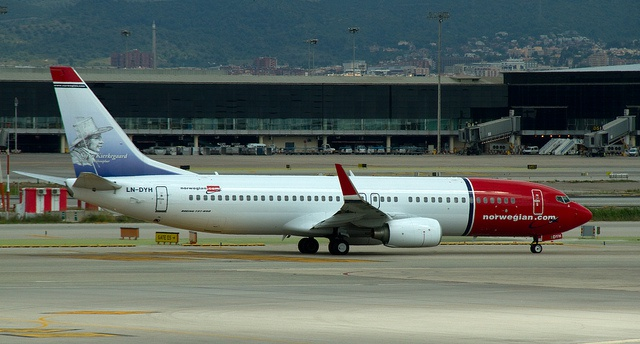Describe the objects in this image and their specific colors. I can see a airplane in blue, lightblue, darkgray, black, and gray tones in this image. 